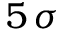Convert formula to latex. <formula><loc_0><loc_0><loc_500><loc_500>5 \, \sigma</formula> 